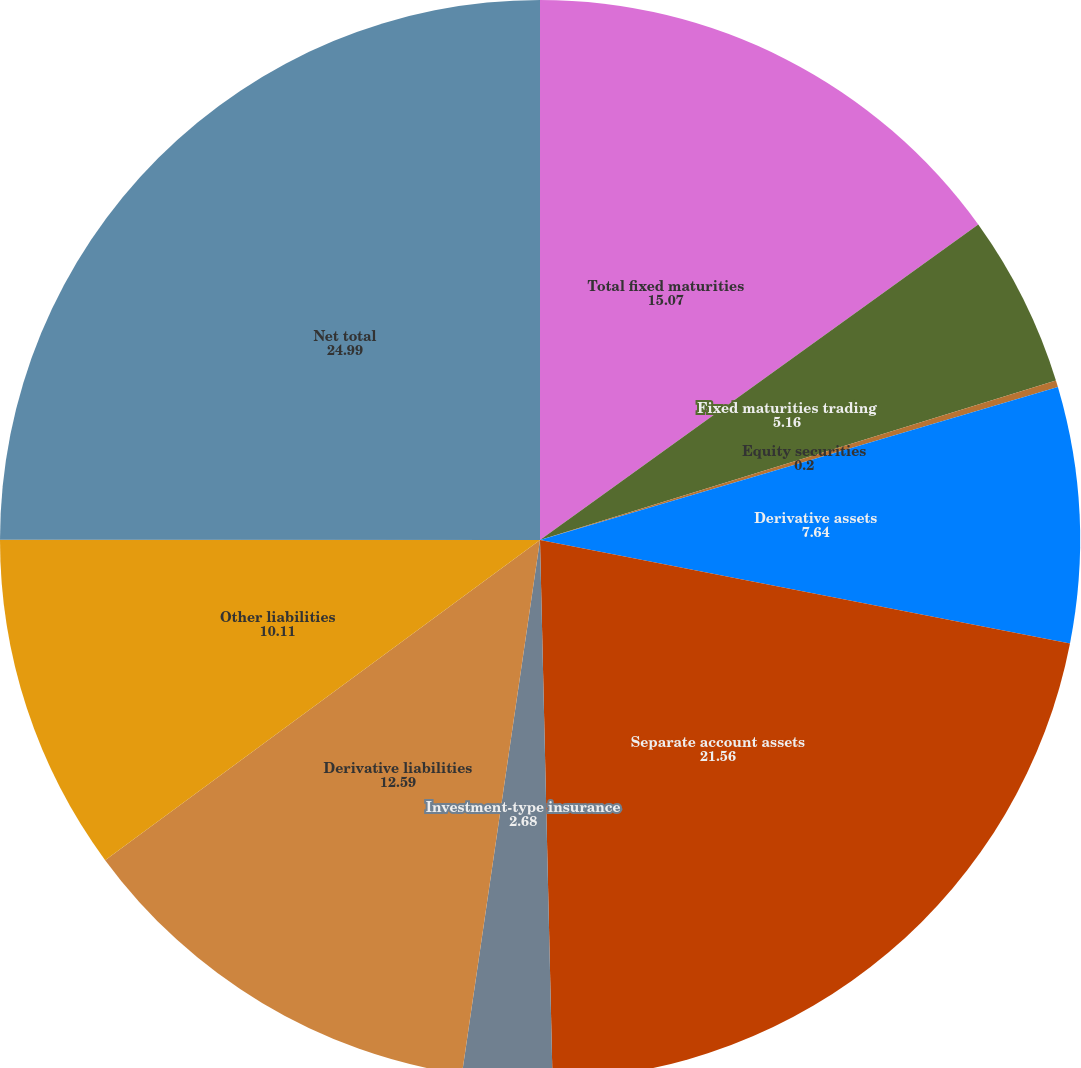Convert chart. <chart><loc_0><loc_0><loc_500><loc_500><pie_chart><fcel>Total fixed maturities<fcel>Fixed maturities trading<fcel>Equity securities<fcel>Derivative assets<fcel>Separate account assets<fcel>Investment-type insurance<fcel>Derivative liabilities<fcel>Other liabilities<fcel>Net total<nl><fcel>15.07%<fcel>5.16%<fcel>0.2%<fcel>7.64%<fcel>21.56%<fcel>2.68%<fcel>12.59%<fcel>10.11%<fcel>24.99%<nl></chart> 